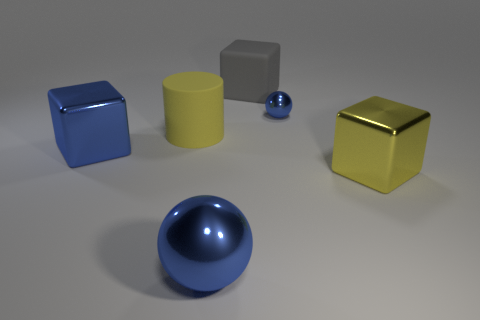Add 2 big objects. How many objects exist? 8 Subtract all spheres. How many objects are left? 4 Subtract 0 red blocks. How many objects are left? 6 Subtract all big gray cubes. Subtract all large matte things. How many objects are left? 3 Add 2 rubber things. How many rubber things are left? 4 Add 5 matte cylinders. How many matte cylinders exist? 6 